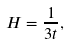<formula> <loc_0><loc_0><loc_500><loc_500>H = \frac { 1 } { 3 t } ,</formula> 